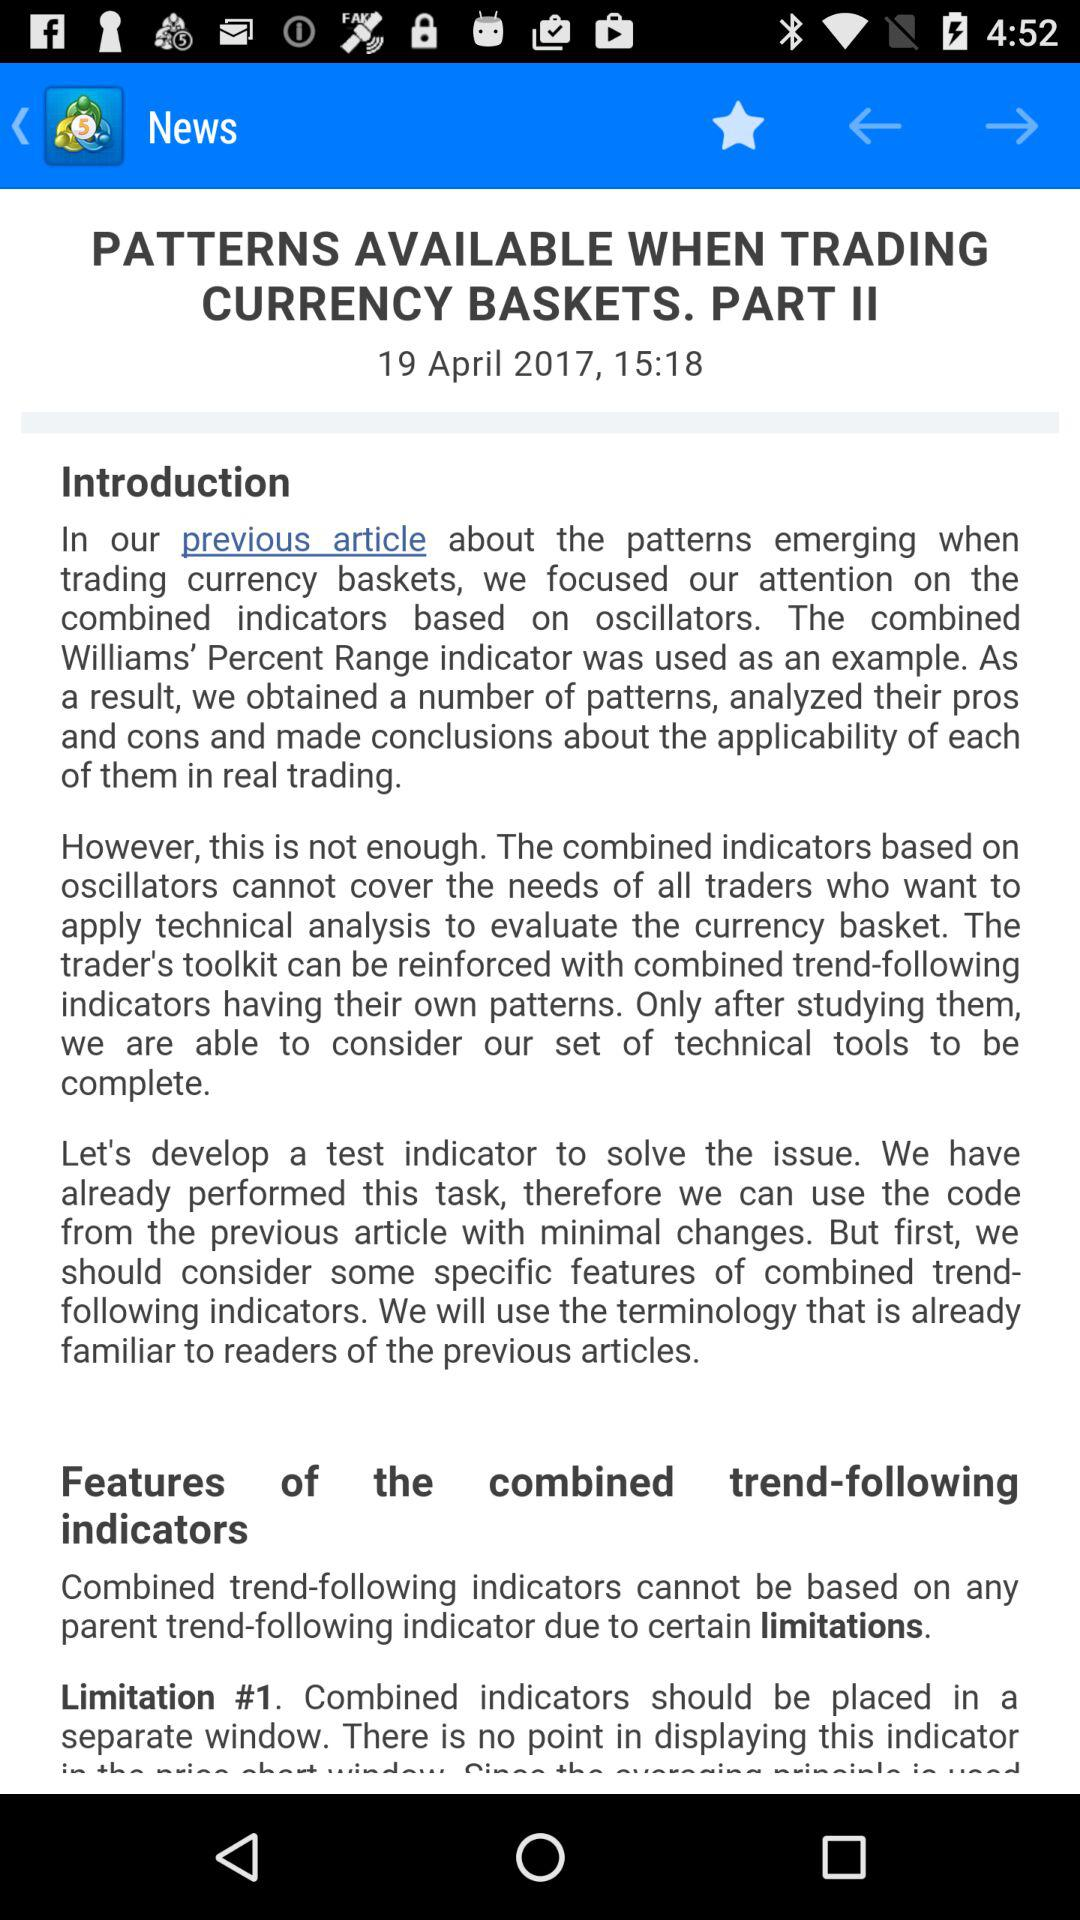What date is displayed on the screen? The displayed date is April 19, 2017. 